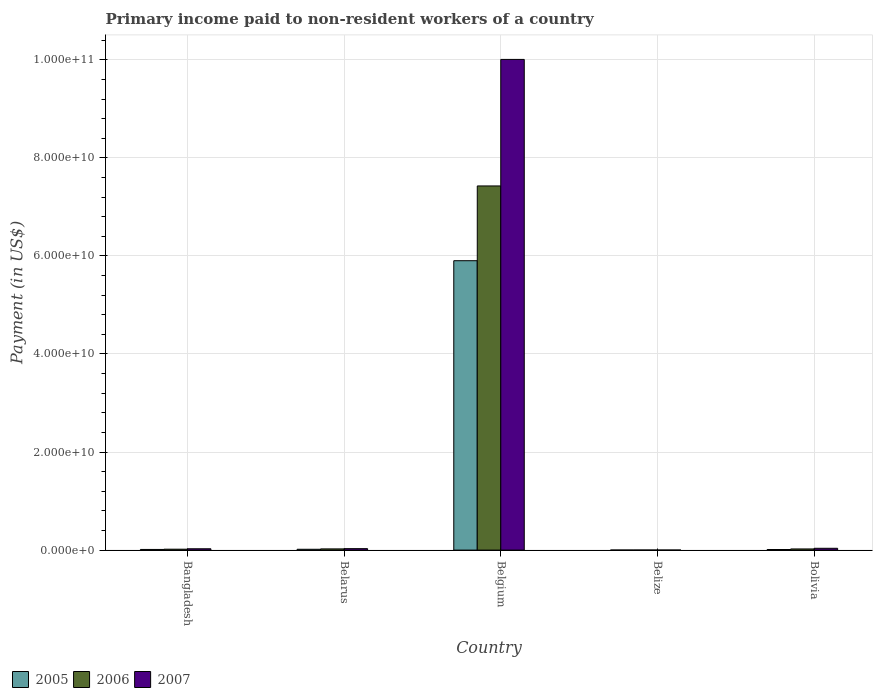How many different coloured bars are there?
Provide a succinct answer. 3. How many groups of bars are there?
Give a very brief answer. 5. Are the number of bars per tick equal to the number of legend labels?
Ensure brevity in your answer.  Yes. What is the label of the 1st group of bars from the left?
Provide a short and direct response. Bangladesh. What is the amount paid to workers in 2007 in Belgium?
Your answer should be compact. 1.00e+11. Across all countries, what is the maximum amount paid to workers in 2006?
Your response must be concise. 7.43e+1. Across all countries, what is the minimum amount paid to workers in 2007?
Provide a short and direct response. 6.97e+06. In which country was the amount paid to workers in 2006 minimum?
Offer a terse response. Belize. What is the total amount paid to workers in 2007 in the graph?
Offer a terse response. 1.01e+11. What is the difference between the amount paid to workers in 2005 in Belarus and that in Belize?
Provide a succinct answer. 1.62e+08. What is the difference between the amount paid to workers in 2005 in Bolivia and the amount paid to workers in 2006 in Belize?
Offer a very short reply. 1.11e+08. What is the average amount paid to workers in 2006 per country?
Ensure brevity in your answer.  1.50e+1. What is the difference between the amount paid to workers of/in 2005 and amount paid to workers of/in 2007 in Belize?
Your response must be concise. -1.86e+05. What is the ratio of the amount paid to workers in 2007 in Belarus to that in Bolivia?
Your answer should be very brief. 0.8. What is the difference between the highest and the second highest amount paid to workers in 2005?
Your response must be concise. 3.32e+07. What is the difference between the highest and the lowest amount paid to workers in 2005?
Your response must be concise. 5.90e+1. How many bars are there?
Provide a short and direct response. 15. Are all the bars in the graph horizontal?
Make the answer very short. No. What is the difference between two consecutive major ticks on the Y-axis?
Provide a succinct answer. 2.00e+1. Are the values on the major ticks of Y-axis written in scientific E-notation?
Ensure brevity in your answer.  Yes. How are the legend labels stacked?
Offer a terse response. Horizontal. What is the title of the graph?
Keep it short and to the point. Primary income paid to non-resident workers of a country. Does "2010" appear as one of the legend labels in the graph?
Provide a short and direct response. No. What is the label or title of the X-axis?
Your answer should be compact. Country. What is the label or title of the Y-axis?
Provide a short and direct response. Payment (in US$). What is the Payment (in US$) in 2005 in Bangladesh?
Provide a short and direct response. 1.35e+08. What is the Payment (in US$) of 2006 in Bangladesh?
Your answer should be compact. 1.84e+08. What is the Payment (in US$) of 2007 in Bangladesh?
Your answer should be compact. 2.72e+08. What is the Payment (in US$) in 2005 in Belarus?
Keep it short and to the point. 1.68e+08. What is the Payment (in US$) in 2006 in Belarus?
Ensure brevity in your answer.  2.47e+08. What is the Payment (in US$) of 2007 in Belarus?
Offer a very short reply. 2.97e+08. What is the Payment (in US$) of 2005 in Belgium?
Offer a very short reply. 5.90e+1. What is the Payment (in US$) of 2006 in Belgium?
Offer a very short reply. 7.43e+1. What is the Payment (in US$) in 2007 in Belgium?
Provide a short and direct response. 1.00e+11. What is the Payment (in US$) of 2005 in Belize?
Provide a succinct answer. 6.78e+06. What is the Payment (in US$) in 2006 in Belize?
Make the answer very short. 1.01e+07. What is the Payment (in US$) in 2007 in Belize?
Ensure brevity in your answer.  6.97e+06. What is the Payment (in US$) in 2005 in Bolivia?
Ensure brevity in your answer.  1.21e+08. What is the Payment (in US$) in 2006 in Bolivia?
Provide a short and direct response. 2.35e+08. What is the Payment (in US$) in 2007 in Bolivia?
Keep it short and to the point. 3.70e+08. Across all countries, what is the maximum Payment (in US$) in 2005?
Make the answer very short. 5.90e+1. Across all countries, what is the maximum Payment (in US$) of 2006?
Your answer should be very brief. 7.43e+1. Across all countries, what is the maximum Payment (in US$) of 2007?
Keep it short and to the point. 1.00e+11. Across all countries, what is the minimum Payment (in US$) in 2005?
Keep it short and to the point. 6.78e+06. Across all countries, what is the minimum Payment (in US$) in 2006?
Your answer should be very brief. 1.01e+07. Across all countries, what is the minimum Payment (in US$) of 2007?
Your response must be concise. 6.97e+06. What is the total Payment (in US$) in 2005 in the graph?
Offer a terse response. 5.95e+1. What is the total Payment (in US$) in 2006 in the graph?
Your answer should be compact. 7.50e+1. What is the total Payment (in US$) in 2007 in the graph?
Give a very brief answer. 1.01e+11. What is the difference between the Payment (in US$) in 2005 in Bangladesh and that in Belarus?
Offer a terse response. -3.32e+07. What is the difference between the Payment (in US$) of 2006 in Bangladesh and that in Belarus?
Provide a short and direct response. -6.22e+07. What is the difference between the Payment (in US$) in 2007 in Bangladesh and that in Belarus?
Your answer should be compact. -2.54e+07. What is the difference between the Payment (in US$) of 2005 in Bangladesh and that in Belgium?
Provide a short and direct response. -5.89e+1. What is the difference between the Payment (in US$) of 2006 in Bangladesh and that in Belgium?
Offer a terse response. -7.41e+1. What is the difference between the Payment (in US$) in 2007 in Bangladesh and that in Belgium?
Provide a succinct answer. -9.98e+1. What is the difference between the Payment (in US$) in 2005 in Bangladesh and that in Belize?
Give a very brief answer. 1.28e+08. What is the difference between the Payment (in US$) of 2006 in Bangladesh and that in Belize?
Your answer should be very brief. 1.74e+08. What is the difference between the Payment (in US$) in 2007 in Bangladesh and that in Belize?
Provide a succinct answer. 2.65e+08. What is the difference between the Payment (in US$) in 2005 in Bangladesh and that in Bolivia?
Keep it short and to the point. 1.39e+07. What is the difference between the Payment (in US$) of 2006 in Bangladesh and that in Bolivia?
Provide a short and direct response. -5.10e+07. What is the difference between the Payment (in US$) in 2007 in Bangladesh and that in Bolivia?
Offer a very short reply. -9.81e+07. What is the difference between the Payment (in US$) of 2005 in Belarus and that in Belgium?
Provide a short and direct response. -5.89e+1. What is the difference between the Payment (in US$) in 2006 in Belarus and that in Belgium?
Your answer should be very brief. -7.40e+1. What is the difference between the Payment (in US$) in 2007 in Belarus and that in Belgium?
Provide a succinct answer. -9.98e+1. What is the difference between the Payment (in US$) of 2005 in Belarus and that in Belize?
Keep it short and to the point. 1.62e+08. What is the difference between the Payment (in US$) in 2006 in Belarus and that in Belize?
Provide a succinct answer. 2.36e+08. What is the difference between the Payment (in US$) in 2007 in Belarus and that in Belize?
Provide a succinct answer. 2.90e+08. What is the difference between the Payment (in US$) in 2005 in Belarus and that in Bolivia?
Your answer should be very brief. 4.72e+07. What is the difference between the Payment (in US$) of 2006 in Belarus and that in Bolivia?
Your answer should be compact. 1.12e+07. What is the difference between the Payment (in US$) of 2007 in Belarus and that in Bolivia?
Offer a terse response. -7.27e+07. What is the difference between the Payment (in US$) of 2005 in Belgium and that in Belize?
Your answer should be compact. 5.90e+1. What is the difference between the Payment (in US$) of 2006 in Belgium and that in Belize?
Give a very brief answer. 7.43e+1. What is the difference between the Payment (in US$) of 2007 in Belgium and that in Belize?
Give a very brief answer. 1.00e+11. What is the difference between the Payment (in US$) in 2005 in Belgium and that in Bolivia?
Give a very brief answer. 5.89e+1. What is the difference between the Payment (in US$) of 2006 in Belgium and that in Bolivia?
Provide a succinct answer. 7.40e+1. What is the difference between the Payment (in US$) in 2007 in Belgium and that in Bolivia?
Give a very brief answer. 9.97e+1. What is the difference between the Payment (in US$) in 2005 in Belize and that in Bolivia?
Offer a terse response. -1.14e+08. What is the difference between the Payment (in US$) in 2006 in Belize and that in Bolivia?
Ensure brevity in your answer.  -2.25e+08. What is the difference between the Payment (in US$) in 2007 in Belize and that in Bolivia?
Your answer should be compact. -3.63e+08. What is the difference between the Payment (in US$) of 2005 in Bangladesh and the Payment (in US$) of 2006 in Belarus?
Offer a very short reply. -1.11e+08. What is the difference between the Payment (in US$) of 2005 in Bangladesh and the Payment (in US$) of 2007 in Belarus?
Keep it short and to the point. -1.62e+08. What is the difference between the Payment (in US$) of 2006 in Bangladesh and the Payment (in US$) of 2007 in Belarus?
Your response must be concise. -1.13e+08. What is the difference between the Payment (in US$) of 2005 in Bangladesh and the Payment (in US$) of 2006 in Belgium?
Offer a very short reply. -7.41e+1. What is the difference between the Payment (in US$) in 2005 in Bangladesh and the Payment (in US$) in 2007 in Belgium?
Make the answer very short. -1.00e+11. What is the difference between the Payment (in US$) of 2006 in Bangladesh and the Payment (in US$) of 2007 in Belgium?
Offer a terse response. -9.99e+1. What is the difference between the Payment (in US$) of 2005 in Bangladesh and the Payment (in US$) of 2006 in Belize?
Make the answer very short. 1.25e+08. What is the difference between the Payment (in US$) in 2005 in Bangladesh and the Payment (in US$) in 2007 in Belize?
Provide a short and direct response. 1.28e+08. What is the difference between the Payment (in US$) in 2006 in Bangladesh and the Payment (in US$) in 2007 in Belize?
Your response must be concise. 1.77e+08. What is the difference between the Payment (in US$) of 2005 in Bangladesh and the Payment (in US$) of 2006 in Bolivia?
Offer a terse response. -1.00e+08. What is the difference between the Payment (in US$) of 2005 in Bangladesh and the Payment (in US$) of 2007 in Bolivia?
Your answer should be very brief. -2.35e+08. What is the difference between the Payment (in US$) in 2006 in Bangladesh and the Payment (in US$) in 2007 in Bolivia?
Keep it short and to the point. -1.85e+08. What is the difference between the Payment (in US$) in 2005 in Belarus and the Payment (in US$) in 2006 in Belgium?
Provide a short and direct response. -7.41e+1. What is the difference between the Payment (in US$) of 2005 in Belarus and the Payment (in US$) of 2007 in Belgium?
Provide a succinct answer. -9.99e+1. What is the difference between the Payment (in US$) of 2006 in Belarus and the Payment (in US$) of 2007 in Belgium?
Provide a short and direct response. -9.98e+1. What is the difference between the Payment (in US$) of 2005 in Belarus and the Payment (in US$) of 2006 in Belize?
Your answer should be very brief. 1.58e+08. What is the difference between the Payment (in US$) of 2005 in Belarus and the Payment (in US$) of 2007 in Belize?
Provide a short and direct response. 1.61e+08. What is the difference between the Payment (in US$) of 2006 in Belarus and the Payment (in US$) of 2007 in Belize?
Offer a very short reply. 2.40e+08. What is the difference between the Payment (in US$) of 2005 in Belarus and the Payment (in US$) of 2006 in Bolivia?
Offer a very short reply. -6.70e+07. What is the difference between the Payment (in US$) in 2005 in Belarus and the Payment (in US$) in 2007 in Bolivia?
Your answer should be compact. -2.01e+08. What is the difference between the Payment (in US$) of 2006 in Belarus and the Payment (in US$) of 2007 in Bolivia?
Offer a very short reply. -1.23e+08. What is the difference between the Payment (in US$) of 2005 in Belgium and the Payment (in US$) of 2006 in Belize?
Provide a short and direct response. 5.90e+1. What is the difference between the Payment (in US$) of 2005 in Belgium and the Payment (in US$) of 2007 in Belize?
Offer a terse response. 5.90e+1. What is the difference between the Payment (in US$) in 2006 in Belgium and the Payment (in US$) in 2007 in Belize?
Your answer should be compact. 7.43e+1. What is the difference between the Payment (in US$) of 2005 in Belgium and the Payment (in US$) of 2006 in Bolivia?
Give a very brief answer. 5.88e+1. What is the difference between the Payment (in US$) in 2005 in Belgium and the Payment (in US$) in 2007 in Bolivia?
Provide a succinct answer. 5.87e+1. What is the difference between the Payment (in US$) in 2006 in Belgium and the Payment (in US$) in 2007 in Bolivia?
Your response must be concise. 7.39e+1. What is the difference between the Payment (in US$) of 2005 in Belize and the Payment (in US$) of 2006 in Bolivia?
Your response must be concise. -2.29e+08. What is the difference between the Payment (in US$) in 2005 in Belize and the Payment (in US$) in 2007 in Bolivia?
Keep it short and to the point. -3.63e+08. What is the difference between the Payment (in US$) of 2006 in Belize and the Payment (in US$) of 2007 in Bolivia?
Your response must be concise. -3.60e+08. What is the average Payment (in US$) in 2005 per country?
Offer a very short reply. 1.19e+1. What is the average Payment (in US$) of 2006 per country?
Keep it short and to the point. 1.50e+1. What is the average Payment (in US$) of 2007 per country?
Keep it short and to the point. 2.02e+1. What is the difference between the Payment (in US$) of 2005 and Payment (in US$) of 2006 in Bangladesh?
Ensure brevity in your answer.  -4.93e+07. What is the difference between the Payment (in US$) in 2005 and Payment (in US$) in 2007 in Bangladesh?
Your response must be concise. -1.37e+08. What is the difference between the Payment (in US$) of 2006 and Payment (in US$) of 2007 in Bangladesh?
Offer a terse response. -8.73e+07. What is the difference between the Payment (in US$) of 2005 and Payment (in US$) of 2006 in Belarus?
Make the answer very short. -7.82e+07. What is the difference between the Payment (in US$) in 2005 and Payment (in US$) in 2007 in Belarus?
Give a very brief answer. -1.29e+08. What is the difference between the Payment (in US$) of 2006 and Payment (in US$) of 2007 in Belarus?
Make the answer very short. -5.05e+07. What is the difference between the Payment (in US$) in 2005 and Payment (in US$) in 2006 in Belgium?
Make the answer very short. -1.52e+1. What is the difference between the Payment (in US$) in 2005 and Payment (in US$) in 2007 in Belgium?
Offer a terse response. -4.11e+1. What is the difference between the Payment (in US$) in 2006 and Payment (in US$) in 2007 in Belgium?
Provide a succinct answer. -2.58e+1. What is the difference between the Payment (in US$) of 2005 and Payment (in US$) of 2006 in Belize?
Keep it short and to the point. -3.32e+06. What is the difference between the Payment (in US$) of 2005 and Payment (in US$) of 2007 in Belize?
Make the answer very short. -1.86e+05. What is the difference between the Payment (in US$) in 2006 and Payment (in US$) in 2007 in Belize?
Keep it short and to the point. 3.13e+06. What is the difference between the Payment (in US$) in 2005 and Payment (in US$) in 2006 in Bolivia?
Ensure brevity in your answer.  -1.14e+08. What is the difference between the Payment (in US$) in 2005 and Payment (in US$) in 2007 in Bolivia?
Keep it short and to the point. -2.49e+08. What is the difference between the Payment (in US$) in 2006 and Payment (in US$) in 2007 in Bolivia?
Make the answer very short. -1.34e+08. What is the ratio of the Payment (in US$) in 2005 in Bangladesh to that in Belarus?
Make the answer very short. 0.8. What is the ratio of the Payment (in US$) of 2006 in Bangladesh to that in Belarus?
Your answer should be compact. 0.75. What is the ratio of the Payment (in US$) of 2007 in Bangladesh to that in Belarus?
Offer a terse response. 0.91. What is the ratio of the Payment (in US$) in 2005 in Bangladesh to that in Belgium?
Your response must be concise. 0. What is the ratio of the Payment (in US$) in 2006 in Bangladesh to that in Belgium?
Make the answer very short. 0. What is the ratio of the Payment (in US$) in 2007 in Bangladesh to that in Belgium?
Offer a very short reply. 0. What is the ratio of the Payment (in US$) in 2005 in Bangladesh to that in Belize?
Offer a terse response. 19.93. What is the ratio of the Payment (in US$) of 2006 in Bangladesh to that in Belize?
Provide a succinct answer. 18.26. What is the ratio of the Payment (in US$) in 2007 in Bangladesh to that in Belize?
Offer a very short reply. 39. What is the ratio of the Payment (in US$) of 2005 in Bangladesh to that in Bolivia?
Give a very brief answer. 1.11. What is the ratio of the Payment (in US$) in 2006 in Bangladesh to that in Bolivia?
Ensure brevity in your answer.  0.78. What is the ratio of the Payment (in US$) in 2007 in Bangladesh to that in Bolivia?
Keep it short and to the point. 0.73. What is the ratio of the Payment (in US$) in 2005 in Belarus to that in Belgium?
Your answer should be compact. 0. What is the ratio of the Payment (in US$) in 2006 in Belarus to that in Belgium?
Provide a short and direct response. 0. What is the ratio of the Payment (in US$) in 2007 in Belarus to that in Belgium?
Your answer should be compact. 0. What is the ratio of the Payment (in US$) of 2005 in Belarus to that in Belize?
Ensure brevity in your answer.  24.83. What is the ratio of the Payment (in US$) of 2006 in Belarus to that in Belize?
Make the answer very short. 24.41. What is the ratio of the Payment (in US$) of 2007 in Belarus to that in Belize?
Ensure brevity in your answer.  42.65. What is the ratio of the Payment (in US$) of 2005 in Belarus to that in Bolivia?
Offer a very short reply. 1.39. What is the ratio of the Payment (in US$) in 2006 in Belarus to that in Bolivia?
Provide a short and direct response. 1.05. What is the ratio of the Payment (in US$) in 2007 in Belarus to that in Bolivia?
Offer a very short reply. 0.8. What is the ratio of the Payment (in US$) of 2005 in Belgium to that in Belize?
Give a very brief answer. 8704.96. What is the ratio of the Payment (in US$) in 2006 in Belgium to that in Belize?
Offer a very short reply. 7353.89. What is the ratio of the Payment (in US$) of 2007 in Belgium to that in Belize?
Your response must be concise. 1.44e+04. What is the ratio of the Payment (in US$) in 2005 in Belgium to that in Bolivia?
Offer a very short reply. 486.92. What is the ratio of the Payment (in US$) of 2006 in Belgium to that in Bolivia?
Make the answer very short. 315.48. What is the ratio of the Payment (in US$) of 2007 in Belgium to that in Bolivia?
Your answer should be very brief. 270.62. What is the ratio of the Payment (in US$) in 2005 in Belize to that in Bolivia?
Your answer should be very brief. 0.06. What is the ratio of the Payment (in US$) of 2006 in Belize to that in Bolivia?
Ensure brevity in your answer.  0.04. What is the ratio of the Payment (in US$) of 2007 in Belize to that in Bolivia?
Provide a short and direct response. 0.02. What is the difference between the highest and the second highest Payment (in US$) in 2005?
Your answer should be very brief. 5.89e+1. What is the difference between the highest and the second highest Payment (in US$) of 2006?
Offer a very short reply. 7.40e+1. What is the difference between the highest and the second highest Payment (in US$) of 2007?
Your response must be concise. 9.97e+1. What is the difference between the highest and the lowest Payment (in US$) of 2005?
Offer a very short reply. 5.90e+1. What is the difference between the highest and the lowest Payment (in US$) of 2006?
Make the answer very short. 7.43e+1. What is the difference between the highest and the lowest Payment (in US$) in 2007?
Ensure brevity in your answer.  1.00e+11. 